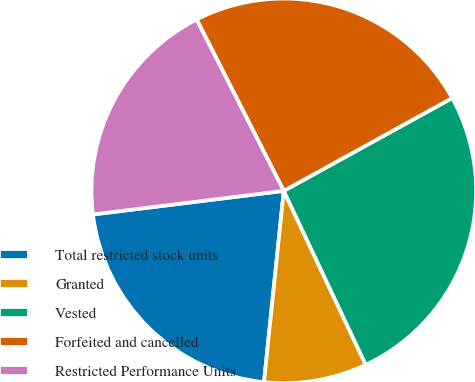Convert chart to OTSL. <chart><loc_0><loc_0><loc_500><loc_500><pie_chart><fcel>Total restricted stock units<fcel>Granted<fcel>Vested<fcel>Forfeited and cancelled<fcel>Restricted Performance Units<nl><fcel>21.4%<fcel>8.65%<fcel>26.01%<fcel>24.47%<fcel>19.47%<nl></chart> 